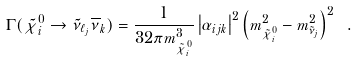<formula> <loc_0><loc_0><loc_500><loc_500>\Gamma ( \tilde { \chi } _ { i } ^ { 0 } \to \tilde { \nu } _ { \ell _ { j } } \overline { \nu } _ { k } ) = \frac { 1 } { 3 2 \pi m _ { \tilde { \chi } _ { i } ^ { 0 } } ^ { 3 } } \left | \alpha _ { i j k } \right | ^ { 2 } \left ( m _ { \tilde { \chi } _ { i } ^ { 0 } } ^ { 2 } - m _ { \tilde { \nu } _ { j } } ^ { 2 } \right ) ^ { 2 } \ .</formula> 